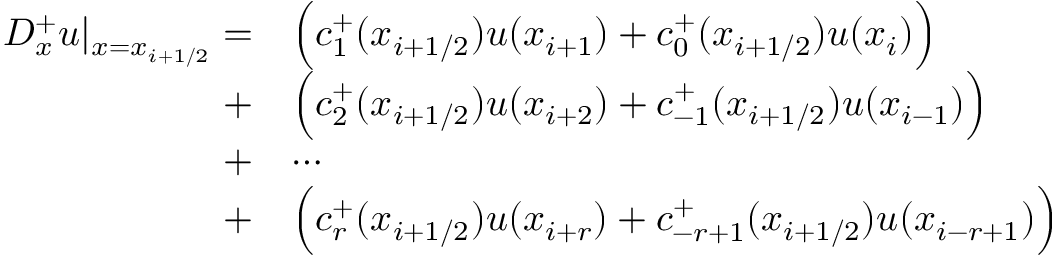<formula> <loc_0><loc_0><loc_500><loc_500>\begin{array} { r l } { D _ { x } ^ { + } u | _ { x = x _ { i + 1 / 2 } } = } & { \left ( c _ { 1 } ^ { + } ( x _ { i + 1 / 2 } ) u ( x _ { i + 1 } ) + c _ { 0 } ^ { + } ( x _ { i + 1 / 2 } ) u ( x _ { i } ) \right ) } \\ { + } & { \left ( c _ { 2 } ^ { + } ( x _ { i + 1 / 2 } ) u ( x _ { i + 2 } ) + c _ { - 1 } ^ { + } ( x _ { i + 1 / 2 } ) u ( x _ { i - 1 } ) \right ) } \\ { + } & { \cdots } \\ { + } & { \left ( c _ { r } ^ { + } ( x _ { i + 1 / 2 } ) u ( x _ { i + r } ) + c _ { - r + 1 } ^ { + } ( x _ { i + 1 / 2 } ) u ( x _ { i - r + 1 } ) \right ) } \end{array}</formula> 